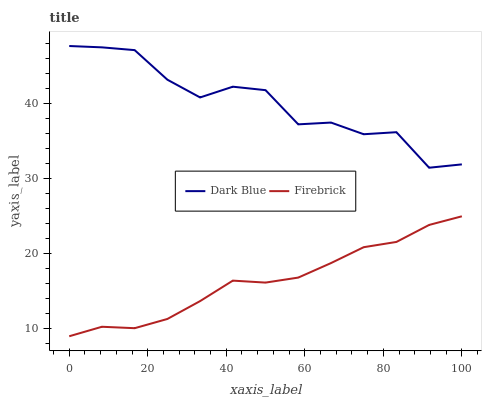Does Firebrick have the minimum area under the curve?
Answer yes or no. Yes. Does Dark Blue have the maximum area under the curve?
Answer yes or no. Yes. Does Firebrick have the maximum area under the curve?
Answer yes or no. No. Is Firebrick the smoothest?
Answer yes or no. Yes. Is Dark Blue the roughest?
Answer yes or no. Yes. Is Firebrick the roughest?
Answer yes or no. No. Does Firebrick have the lowest value?
Answer yes or no. Yes. Does Dark Blue have the highest value?
Answer yes or no. Yes. Does Firebrick have the highest value?
Answer yes or no. No. Is Firebrick less than Dark Blue?
Answer yes or no. Yes. Is Dark Blue greater than Firebrick?
Answer yes or no. Yes. Does Firebrick intersect Dark Blue?
Answer yes or no. No. 